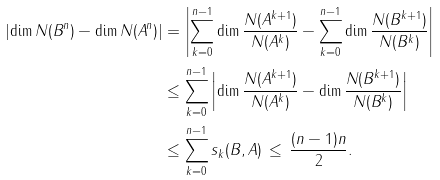Convert formula to latex. <formula><loc_0><loc_0><loc_500><loc_500>\left | \dim N ( B ^ { n } ) - \dim N ( A ^ { n } ) \right | & = \left | \sum _ { k = 0 } ^ { n - 1 } \dim \frac { N ( A ^ { k + 1 } ) } { N ( A ^ { k } ) } - \sum _ { k = 0 } ^ { n - 1 } \dim \frac { N ( B ^ { k + 1 } ) } { N ( B ^ { k } ) } \right | \\ & \leq \sum _ { k = 0 } ^ { n - 1 } \left | \dim \frac { N ( A ^ { k + 1 } ) } { N ( A ^ { k } ) } - \dim \frac { N ( B ^ { k + 1 } ) } { N ( B ^ { k } ) } \right | \\ & \leq \sum _ { k = 0 } ^ { n - 1 } s _ { k } ( B , A ) \, \leq \, \frac { ( n - 1 ) n } { 2 } .</formula> 